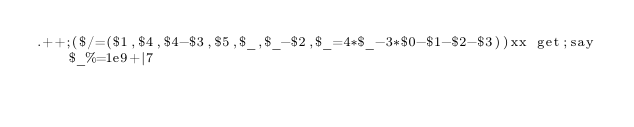<code> <loc_0><loc_0><loc_500><loc_500><_Perl_>.++;($/=($1,$4,$4-$3,$5,$_,$_-$2,$_=4*$_-3*$0-$1-$2-$3))xx get;say $_%=1e9+|7</code> 